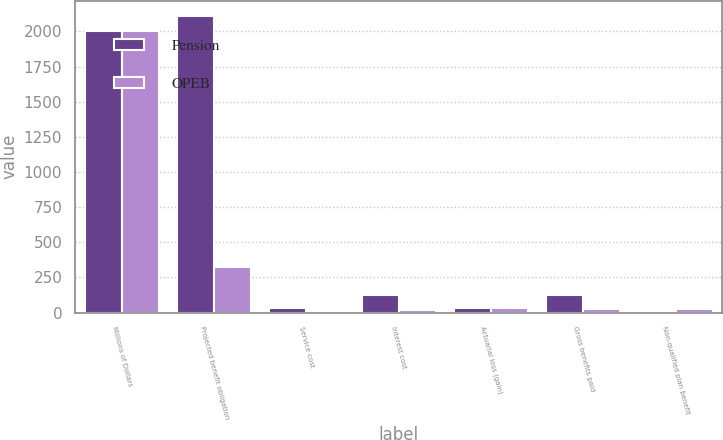Convert chart. <chart><loc_0><loc_0><loc_500><loc_500><stacked_bar_chart><ecel><fcel>Millions of Dollars<fcel>Projected benefit obligation<fcel>Service cost<fcel>Interest cost<fcel>Actuarial loss (gain)<fcel>Gross benefits paid<fcel>Non-qualified plan benefit<nl><fcel>Pension<fcel>2007<fcel>2112<fcel>34<fcel>124<fcel>33<fcel>126<fcel>12<nl><fcel>OPEB<fcel>2007<fcel>326<fcel>3<fcel>20<fcel>34<fcel>27<fcel>27<nl></chart> 